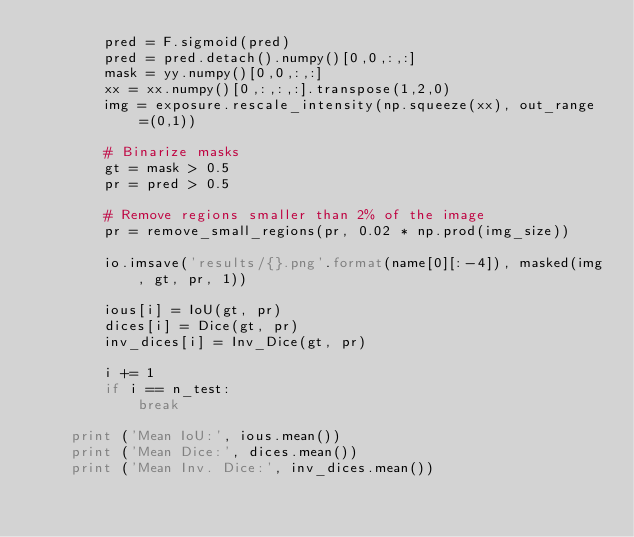Convert code to text. <code><loc_0><loc_0><loc_500><loc_500><_Python_>        pred = F.sigmoid(pred)
        pred = pred.detach().numpy()[0,0,:,:]
        mask = yy.numpy()[0,0,:,:]
        xx = xx.numpy()[0,:,:,:].transpose(1,2,0)
        img = exposure.rescale_intensity(np.squeeze(xx), out_range=(0,1))

        # Binarize masks
        gt = mask > 0.5
        pr = pred > 0.5

        # Remove regions smaller than 2% of the image
        pr = remove_small_regions(pr, 0.02 * np.prod(img_size))

        io.imsave('results/{}.png'.format(name[0][:-4]), masked(img, gt, pr, 1))

        ious[i] = IoU(gt, pr)
        dices[i] = Dice(gt, pr)
        inv_dices[i] = Inv_Dice(gt, pr) 

        i += 1
        if i == n_test:
            break

    print ('Mean IoU:', ious.mean())
    print ('Mean Dice:', dices.mean())
    print ('Mean Inv. Dice:', inv_dices.mean())
    
    
    
</code> 